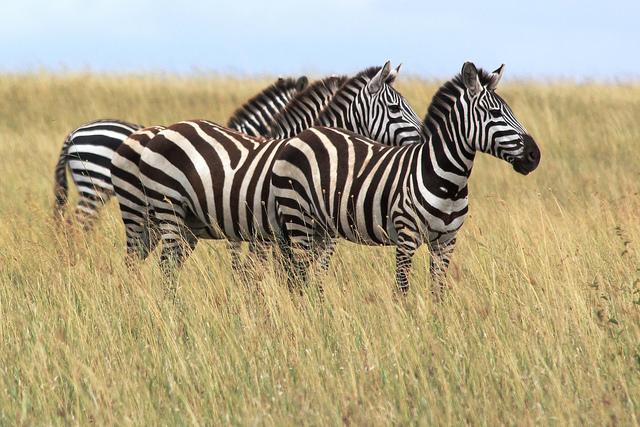Are the zebras facing the same direction?
Answer briefly. Yes. What are the zebra doing?
Answer briefly. Standing. What color are the zebras?
Write a very short answer. Black and white. What color is the grass?
Concise answer only. Yellow. Are the zebras walking?
Write a very short answer. No. 